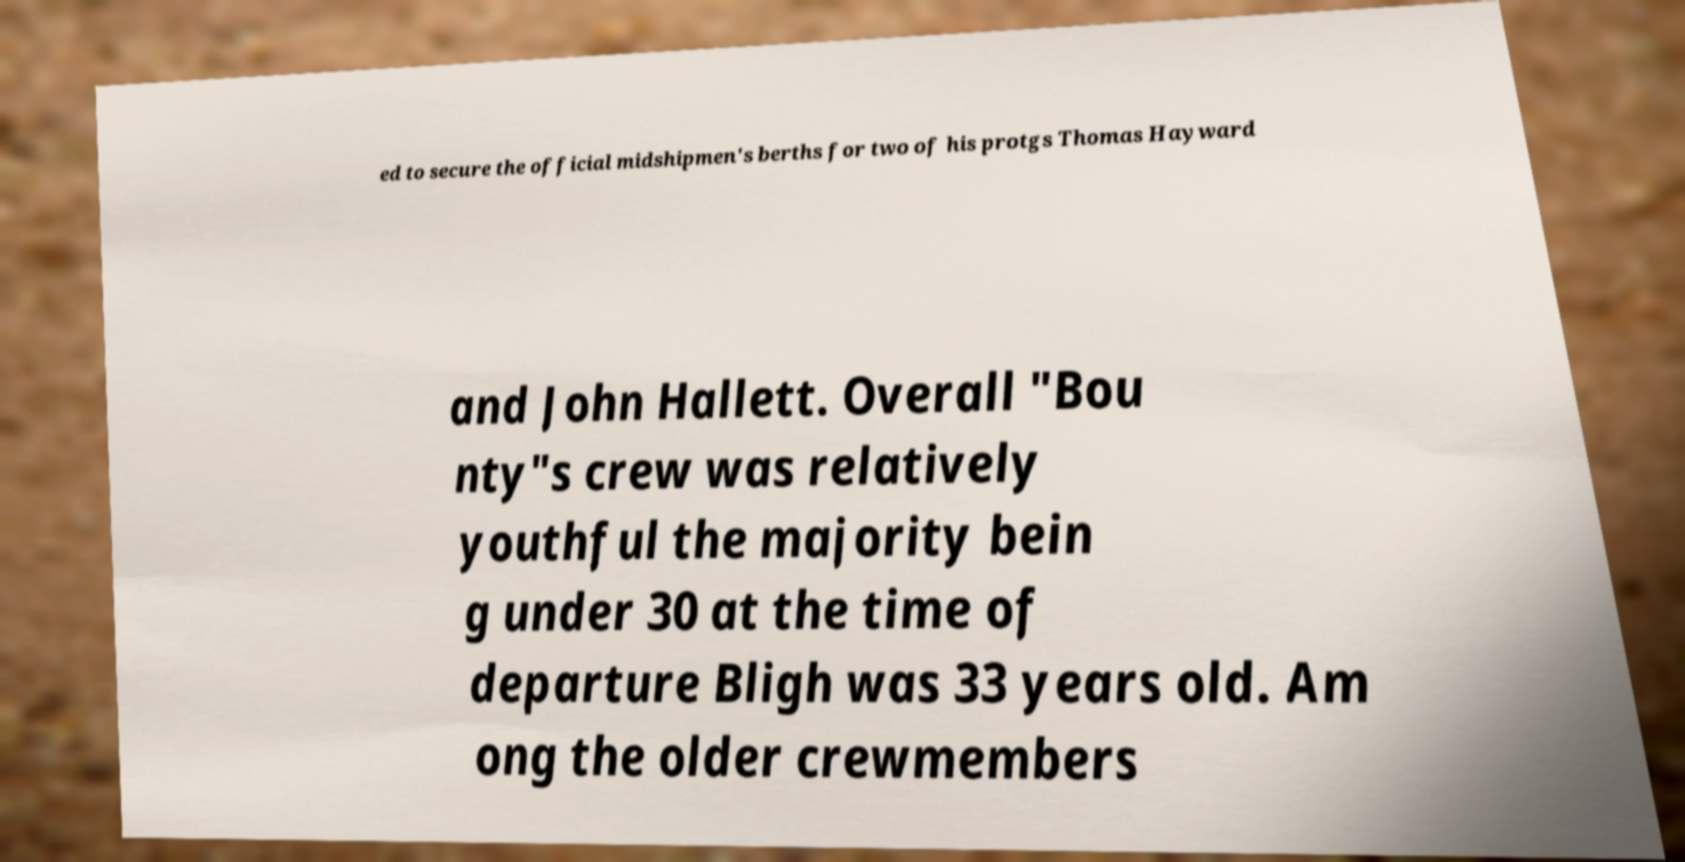Can you read and provide the text displayed in the image?This photo seems to have some interesting text. Can you extract and type it out for me? ed to secure the official midshipmen's berths for two of his protgs Thomas Hayward and John Hallett. Overall "Bou nty"s crew was relatively youthful the majority bein g under 30 at the time of departure Bligh was 33 years old. Am ong the older crewmembers 